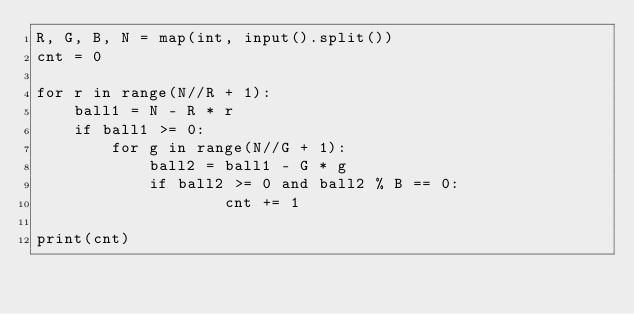<code> <loc_0><loc_0><loc_500><loc_500><_Python_>R, G, B, N = map(int, input().split())
cnt = 0
 
for r in range(N//R + 1):
    ball1 = N - R * r
    if ball1 >= 0:
        for g in range(N//G + 1):
            ball2 = ball1 - G * g
            if ball2 >= 0 and ball2 % B == 0:
                    cnt += 1
 
print(cnt)</code> 